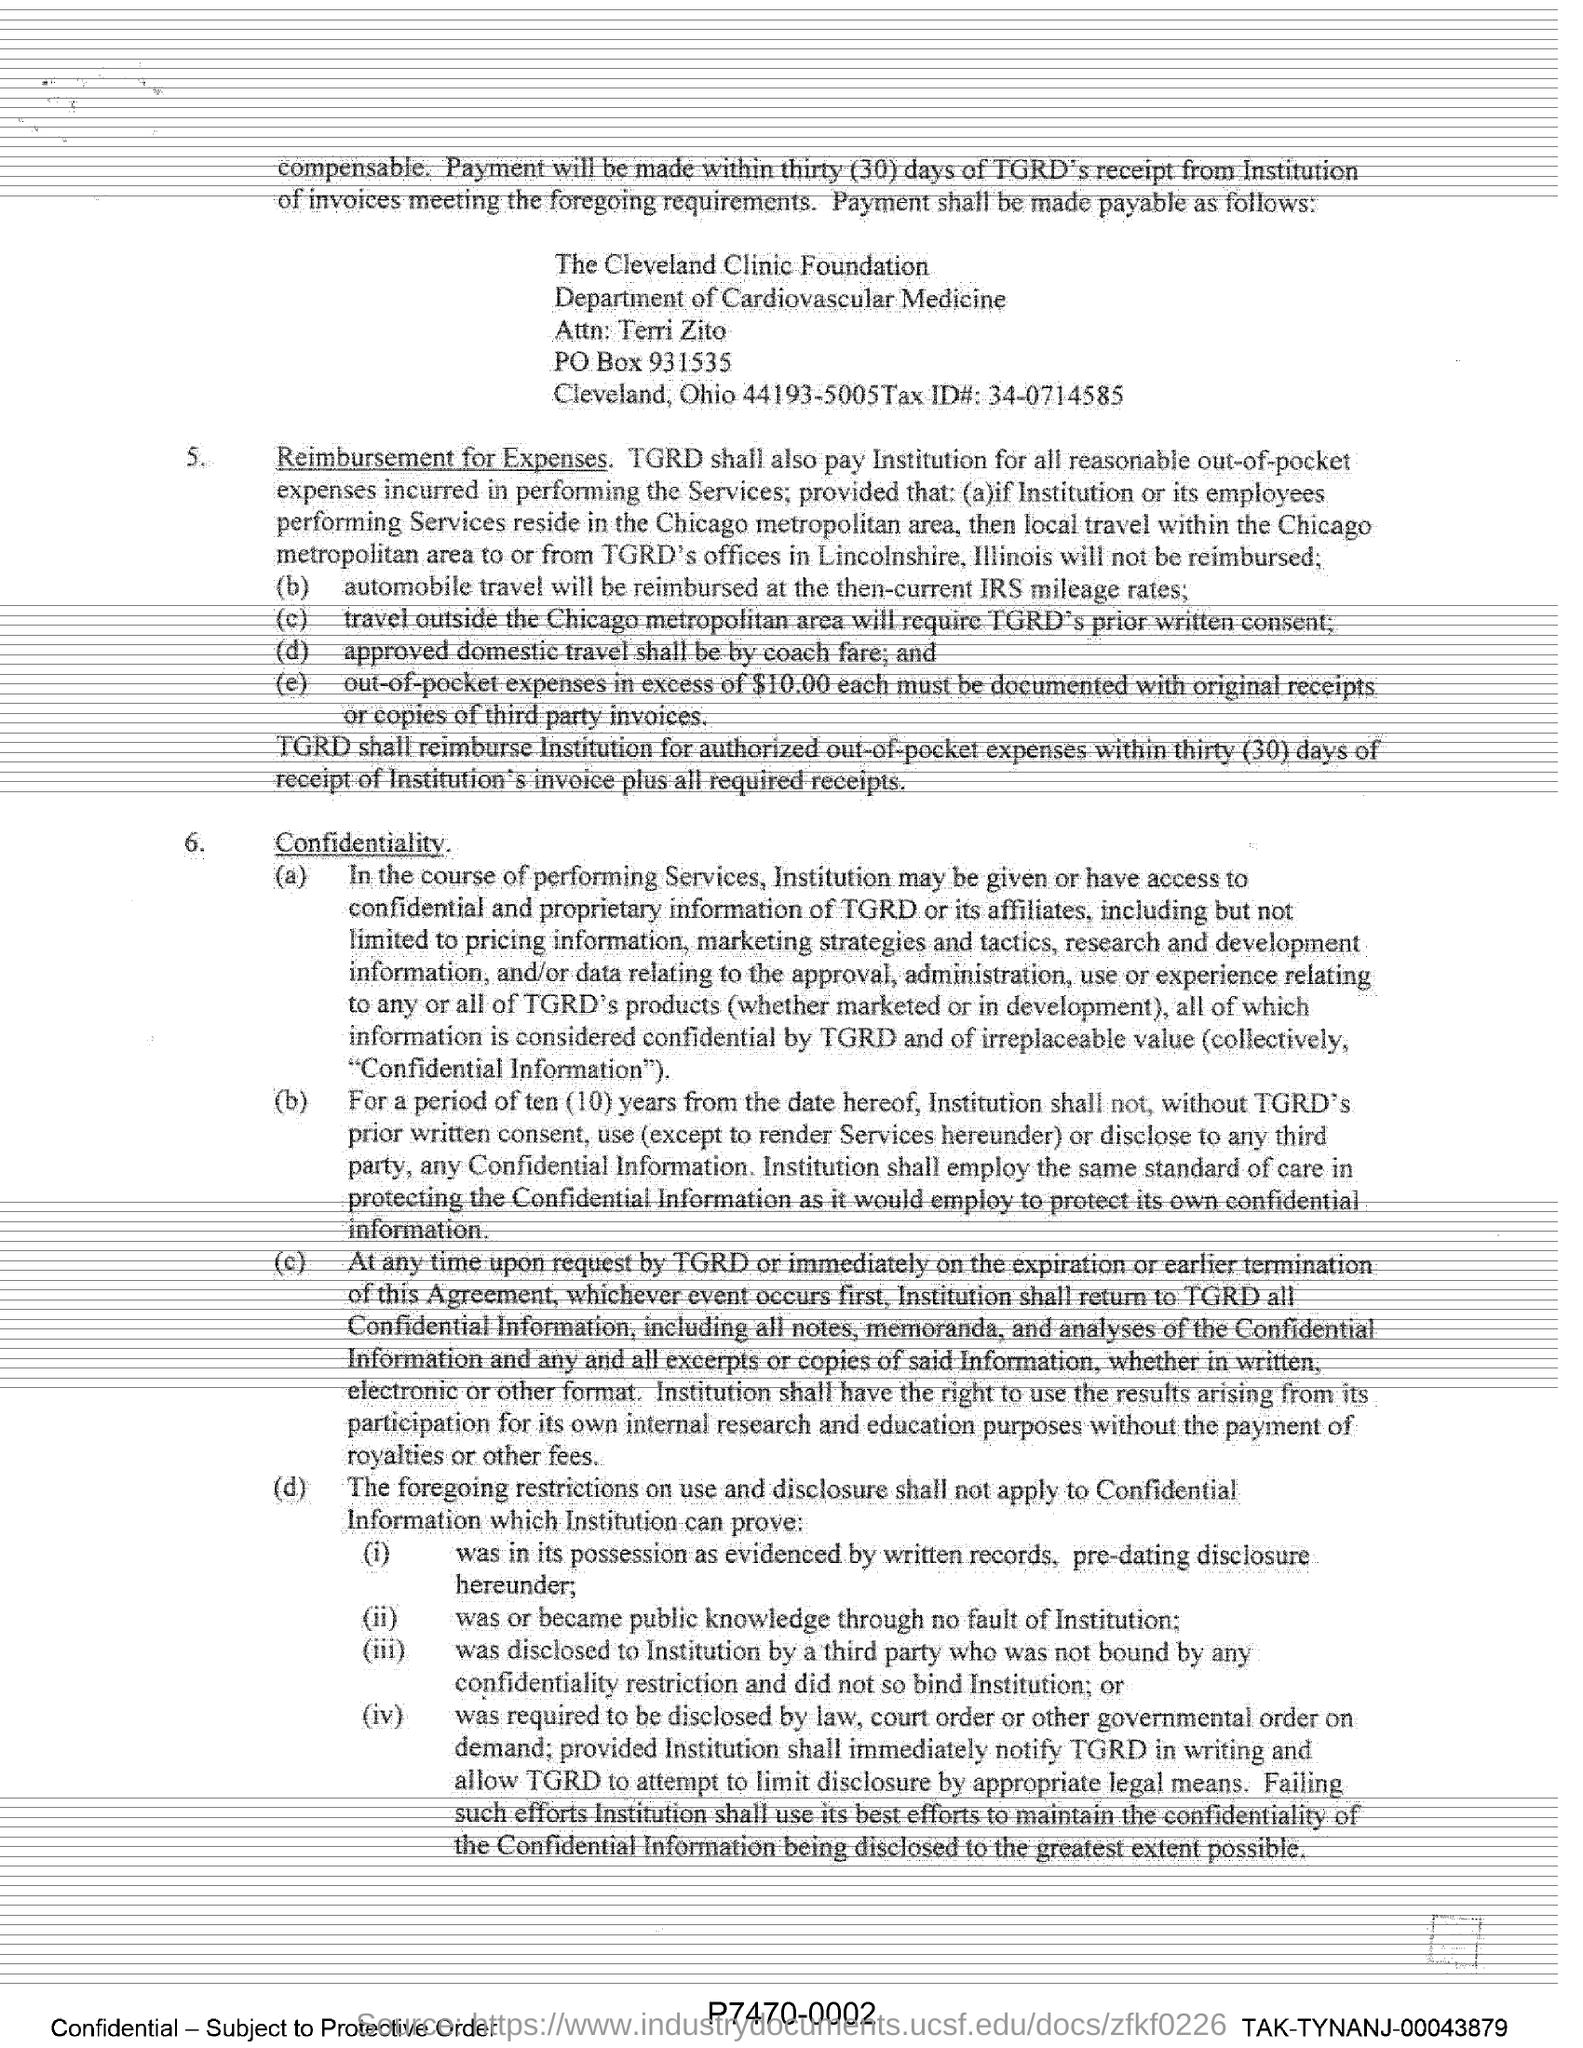Which foundation is mentioned in this document?
Keep it short and to the point. The Cleveland Clinic Foundation. Under which department , The Cleveland Clinic Foundation operates?
Offer a terse response. Department of Cardiovascular Medicine. What is the PO Box number?
Your answer should be very brief. 931535. What is the Tax ID mentioned in this document?
Your answer should be compact. 34-0714585. 